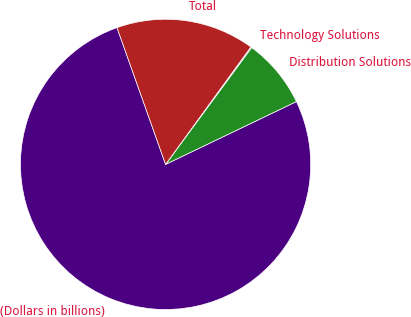<chart> <loc_0><loc_0><loc_500><loc_500><pie_chart><fcel>(Dollars in billions)<fcel>Distribution Solutions<fcel>Technology Solutions<fcel>Total<nl><fcel>76.69%<fcel>7.77%<fcel>0.11%<fcel>15.43%<nl></chart> 